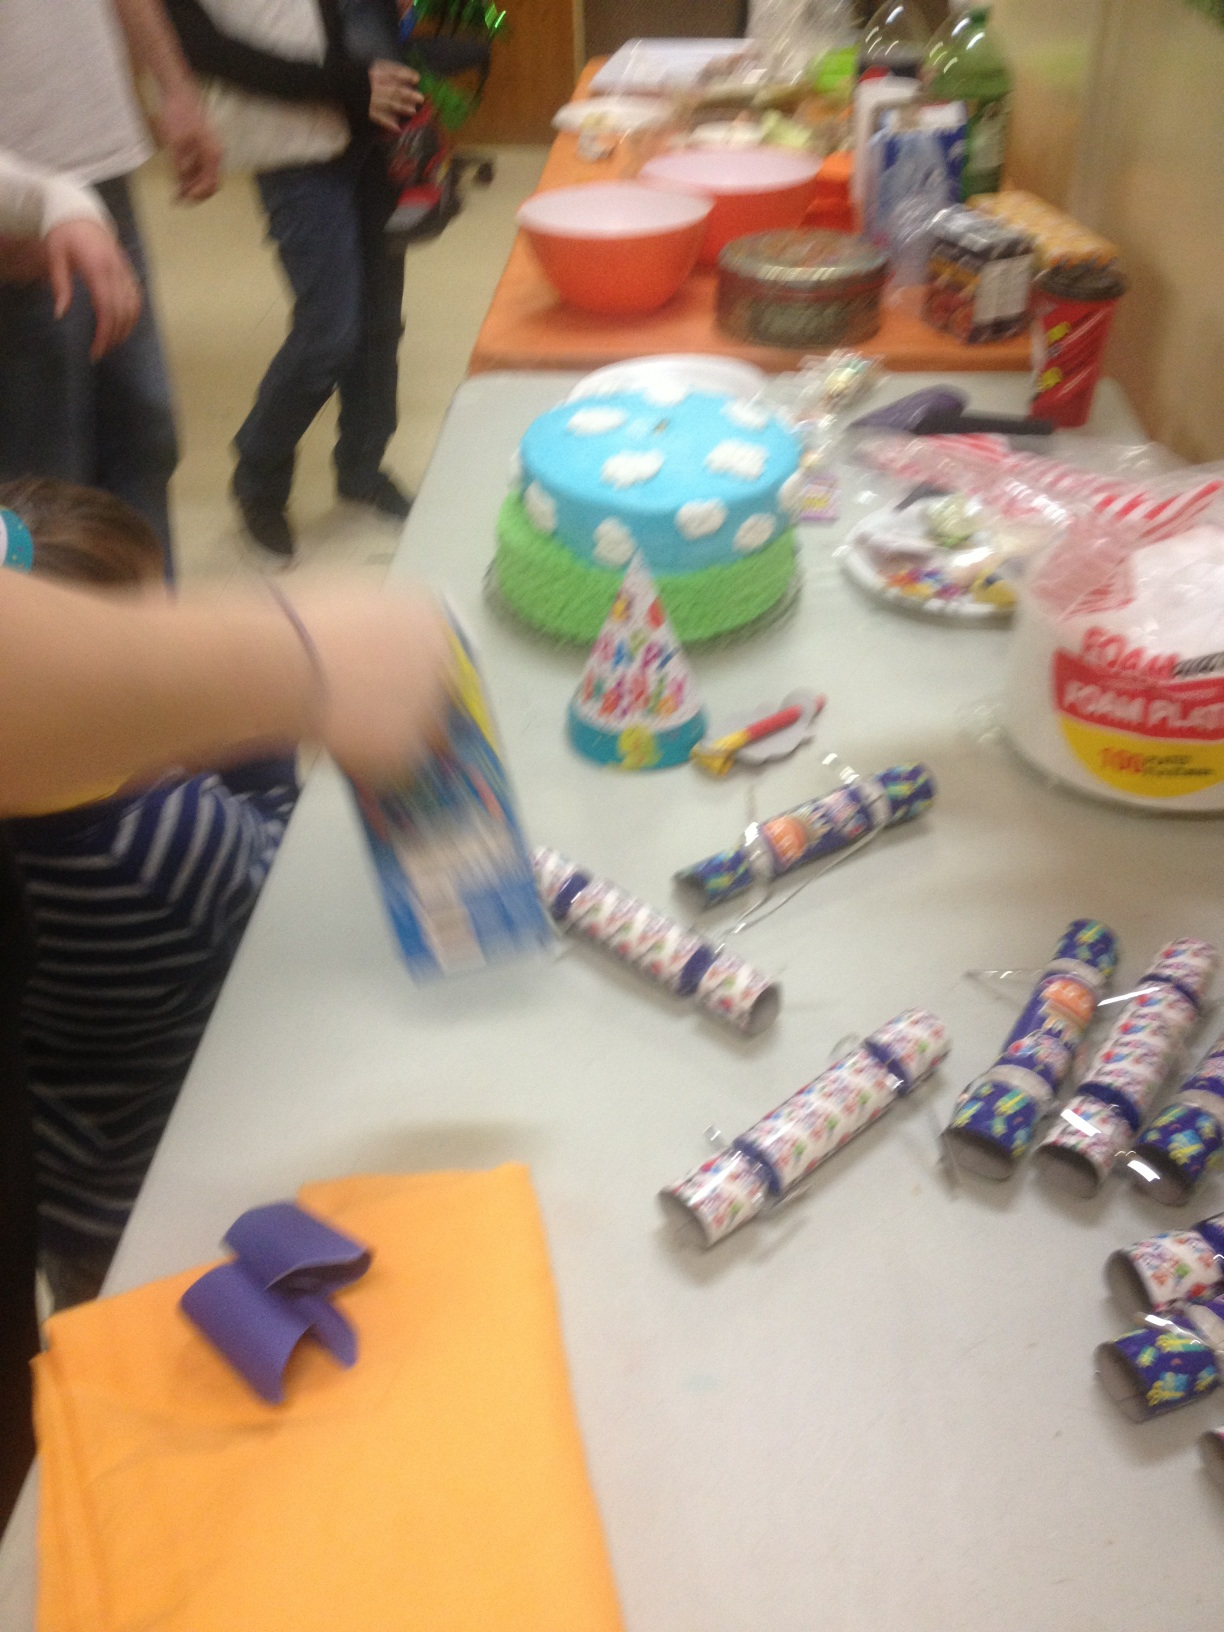What's the occasion here? It looks like a children's birthday party, given the birthday cake, decorations, and party favors laid out on the tables. 